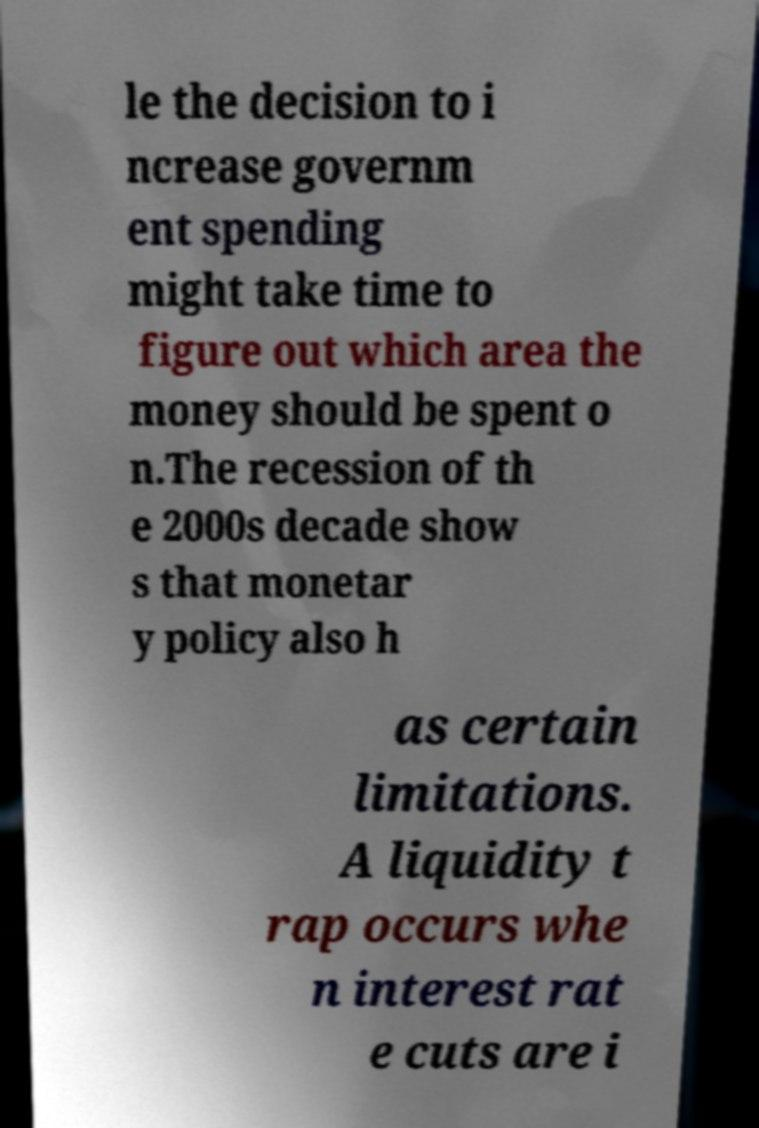There's text embedded in this image that I need extracted. Can you transcribe it verbatim? le the decision to i ncrease governm ent spending might take time to figure out which area the money should be spent o n.The recession of th e 2000s decade show s that monetar y policy also h as certain limitations. A liquidity t rap occurs whe n interest rat e cuts are i 